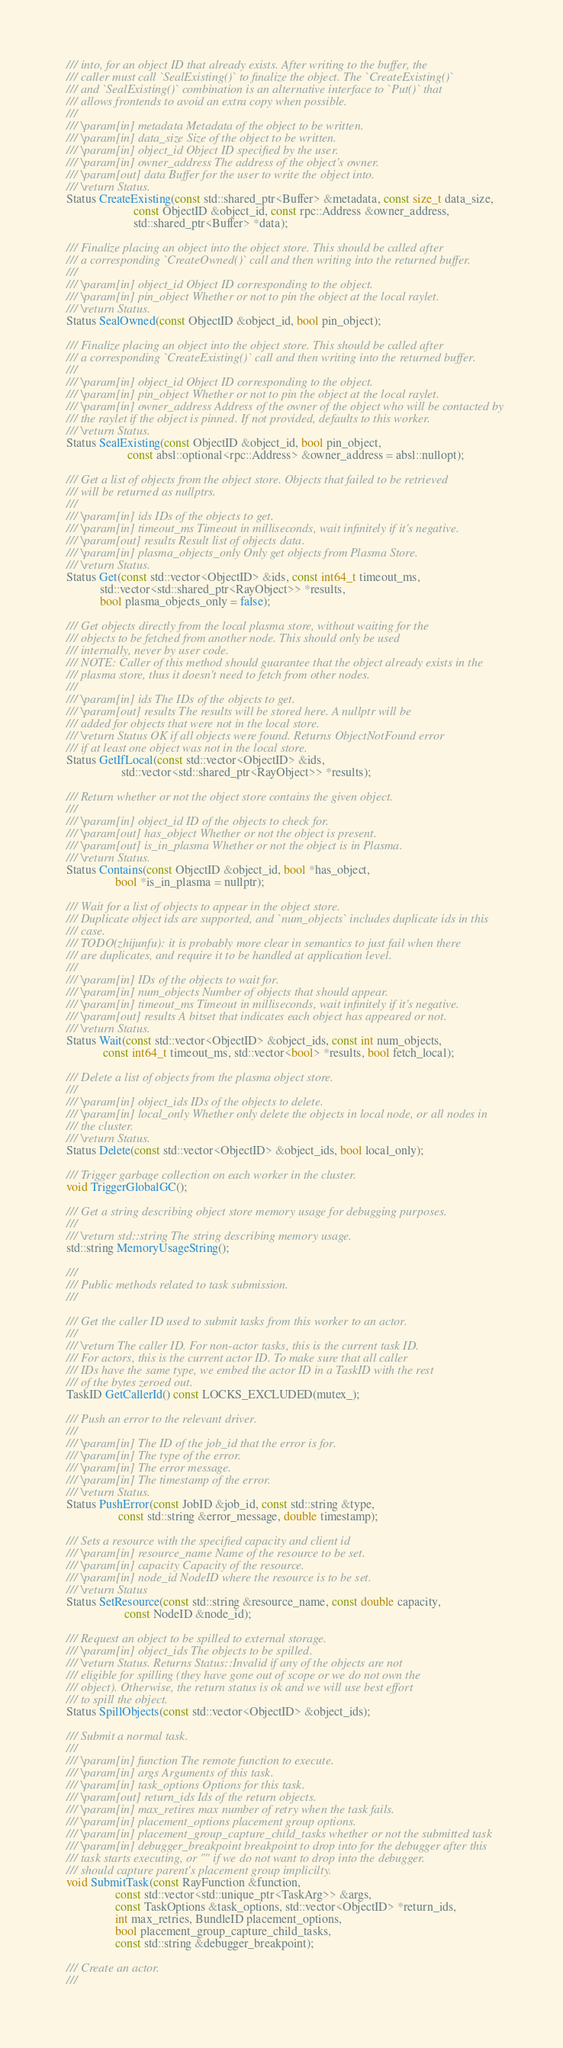<code> <loc_0><loc_0><loc_500><loc_500><_C_>  /// into, for an object ID that already exists. After writing to the buffer, the
  /// caller must call `SealExisting()` to finalize the object. The `CreateExisting()`
  /// and `SealExisting()` combination is an alternative interface to `Put()` that
  /// allows frontends to avoid an extra copy when possible.
  ///
  /// \param[in] metadata Metadata of the object to be written.
  /// \param[in] data_size Size of the object to be written.
  /// \param[in] object_id Object ID specified by the user.
  /// \param[in] owner_address The address of the object's owner.
  /// \param[out] data Buffer for the user to write the object into.
  /// \return Status.
  Status CreateExisting(const std::shared_ptr<Buffer> &metadata, const size_t data_size,
                        const ObjectID &object_id, const rpc::Address &owner_address,
                        std::shared_ptr<Buffer> *data);

  /// Finalize placing an object into the object store. This should be called after
  /// a corresponding `CreateOwned()` call and then writing into the returned buffer.
  ///
  /// \param[in] object_id Object ID corresponding to the object.
  /// \param[in] pin_object Whether or not to pin the object at the local raylet.
  /// \return Status.
  Status SealOwned(const ObjectID &object_id, bool pin_object);

  /// Finalize placing an object into the object store. This should be called after
  /// a corresponding `CreateExisting()` call and then writing into the returned buffer.
  ///
  /// \param[in] object_id Object ID corresponding to the object.
  /// \param[in] pin_object Whether or not to pin the object at the local raylet.
  /// \param[in] owner_address Address of the owner of the object who will be contacted by
  /// the raylet if the object is pinned. If not provided, defaults to this worker.
  /// \return Status.
  Status SealExisting(const ObjectID &object_id, bool pin_object,
                      const absl::optional<rpc::Address> &owner_address = absl::nullopt);

  /// Get a list of objects from the object store. Objects that failed to be retrieved
  /// will be returned as nullptrs.
  ///
  /// \param[in] ids IDs of the objects to get.
  /// \param[in] timeout_ms Timeout in milliseconds, wait infinitely if it's negative.
  /// \param[out] results Result list of objects data.
  /// \param[in] plasma_objects_only Only get objects from Plasma Store.
  /// \return Status.
  Status Get(const std::vector<ObjectID> &ids, const int64_t timeout_ms,
             std::vector<std::shared_ptr<RayObject>> *results,
             bool plasma_objects_only = false);

  /// Get objects directly from the local plasma store, without waiting for the
  /// objects to be fetched from another node. This should only be used
  /// internally, never by user code.
  /// NOTE: Caller of this method should guarantee that the object already exists in the
  /// plasma store, thus it doesn't need to fetch from other nodes.
  ///
  /// \param[in] ids The IDs of the objects to get.
  /// \param[out] results The results will be stored here. A nullptr will be
  /// added for objects that were not in the local store.
  /// \return Status OK if all objects were found. Returns ObjectNotFound error
  /// if at least one object was not in the local store.
  Status GetIfLocal(const std::vector<ObjectID> &ids,
                    std::vector<std::shared_ptr<RayObject>> *results);

  /// Return whether or not the object store contains the given object.
  ///
  /// \param[in] object_id ID of the objects to check for.
  /// \param[out] has_object Whether or not the object is present.
  /// \param[out] is_in_plasma Whether or not the object is in Plasma.
  /// \return Status.
  Status Contains(const ObjectID &object_id, bool *has_object,
                  bool *is_in_plasma = nullptr);

  /// Wait for a list of objects to appear in the object store.
  /// Duplicate object ids are supported, and `num_objects` includes duplicate ids in this
  /// case.
  /// TODO(zhijunfu): it is probably more clear in semantics to just fail when there
  /// are duplicates, and require it to be handled at application level.
  ///
  /// \param[in] IDs of the objects to wait for.
  /// \param[in] num_objects Number of objects that should appear.
  /// \param[in] timeout_ms Timeout in milliseconds, wait infinitely if it's negative.
  /// \param[out] results A bitset that indicates each object has appeared or not.
  /// \return Status.
  Status Wait(const std::vector<ObjectID> &object_ids, const int num_objects,
              const int64_t timeout_ms, std::vector<bool> *results, bool fetch_local);

  /// Delete a list of objects from the plasma object store.
  ///
  /// \param[in] object_ids IDs of the objects to delete.
  /// \param[in] local_only Whether only delete the objects in local node, or all nodes in
  /// the cluster.
  /// \return Status.
  Status Delete(const std::vector<ObjectID> &object_ids, bool local_only);

  /// Trigger garbage collection on each worker in the cluster.
  void TriggerGlobalGC();

  /// Get a string describing object store memory usage for debugging purposes.
  ///
  /// \return std::string The string describing memory usage.
  std::string MemoryUsageString();

  ///
  /// Public methods related to task submission.
  ///

  /// Get the caller ID used to submit tasks from this worker to an actor.
  ///
  /// \return The caller ID. For non-actor tasks, this is the current task ID.
  /// For actors, this is the current actor ID. To make sure that all caller
  /// IDs have the same type, we embed the actor ID in a TaskID with the rest
  /// of the bytes zeroed out.
  TaskID GetCallerId() const LOCKS_EXCLUDED(mutex_);

  /// Push an error to the relevant driver.
  ///
  /// \param[in] The ID of the job_id that the error is for.
  /// \param[in] The type of the error.
  /// \param[in] The error message.
  /// \param[in] The timestamp of the error.
  /// \return Status.
  Status PushError(const JobID &job_id, const std::string &type,
                   const std::string &error_message, double timestamp);

  /// Sets a resource with the specified capacity and client id
  /// \param[in] resource_name Name of the resource to be set.
  /// \param[in] capacity Capacity of the resource.
  /// \param[in] node_id NodeID where the resource is to be set.
  /// \return Status
  Status SetResource(const std::string &resource_name, const double capacity,
                     const NodeID &node_id);

  /// Request an object to be spilled to external storage.
  /// \param[in] object_ids The objects to be spilled.
  /// \return Status. Returns Status::Invalid if any of the objects are not
  /// eligible for spilling (they have gone out of scope or we do not own the
  /// object). Otherwise, the return status is ok and we will use best effort
  /// to spill the object.
  Status SpillObjects(const std::vector<ObjectID> &object_ids);

  /// Submit a normal task.
  ///
  /// \param[in] function The remote function to execute.
  /// \param[in] args Arguments of this task.
  /// \param[in] task_options Options for this task.
  /// \param[out] return_ids Ids of the return objects.
  /// \param[in] max_retires max number of retry when the task fails.
  /// \param[in] placement_options placement group options.
  /// \param[in] placement_group_capture_child_tasks whether or not the submitted task
  /// \param[in] debugger_breakpoint breakpoint to drop into for the debugger after this
  /// task starts executing, or "" if we do not want to drop into the debugger.
  /// should capture parent's placement group implicilty.
  void SubmitTask(const RayFunction &function,
                  const std::vector<std::unique_ptr<TaskArg>> &args,
                  const TaskOptions &task_options, std::vector<ObjectID> *return_ids,
                  int max_retries, BundleID placement_options,
                  bool placement_group_capture_child_tasks,
                  const std::string &debugger_breakpoint);

  /// Create an actor.
  ///</code> 